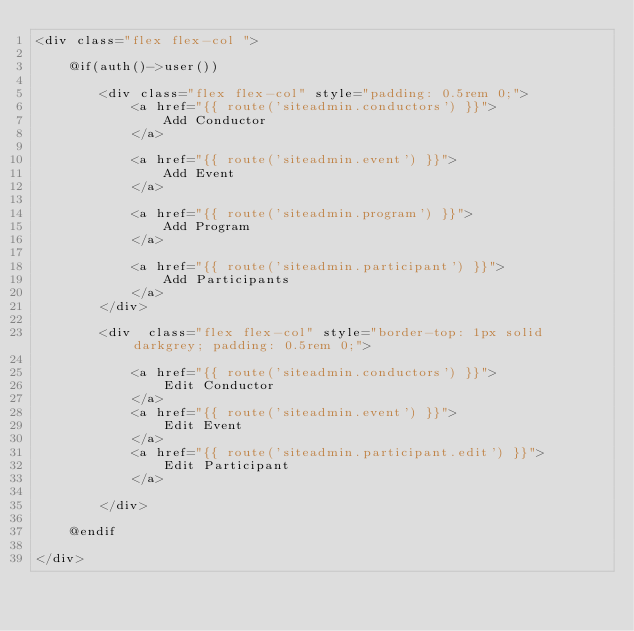<code> <loc_0><loc_0><loc_500><loc_500><_PHP_><div class="flex flex-col ">

    @if(auth()->user())

        <div class="flex flex-col" style="padding: 0.5rem 0;">
            <a href="{{ route('siteadmin.conductors') }}">
                Add Conductor
            </a>

            <a href="{{ route('siteadmin.event') }}">
                Add Event
            </a>

            <a href="{{ route('siteadmin.program') }}">
                Add Program
            </a>

            <a href="{{ route('siteadmin.participant') }}">
                Add Participants
            </a>
        </div>

        <div  class="flex flex-col" style="border-top: 1px solid darkgrey; padding: 0.5rem 0;">

            <a href="{{ route('siteadmin.conductors') }}">
                Edit Conductor
            </a>
            <a href="{{ route('siteadmin.event') }}">
                Edit Event
            </a>
            <a href="{{ route('siteadmin.participant.edit') }}">
                Edit Participant
            </a>

        </div>

    @endif

</div>
</code> 